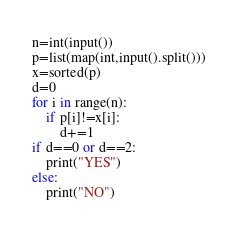<code> <loc_0><loc_0><loc_500><loc_500><_Python_>n=int(input())
p=list(map(int,input().split()))
x=sorted(p)
d=0
for i in range(n):
    if p[i]!=x[i]:
        d+=1
if d==0 or d==2:
    print("YES")
else:
    print("NO")</code> 